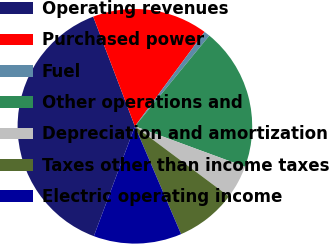Convert chart. <chart><loc_0><loc_0><loc_500><loc_500><pie_chart><fcel>Operating revenues<fcel>Purchased power<fcel>Fuel<fcel>Other operations and<fcel>Depreciation and amortization<fcel>Taxes other than income taxes<fcel>Electric operating income<nl><fcel>38.52%<fcel>15.9%<fcel>0.82%<fcel>19.67%<fcel>4.59%<fcel>8.36%<fcel>12.13%<nl></chart> 